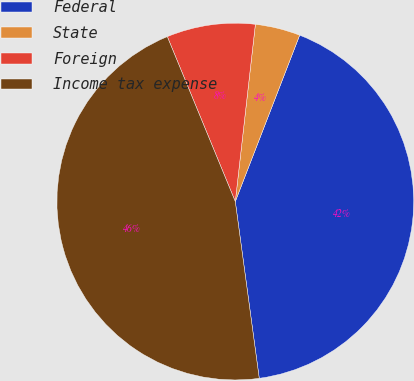Convert chart to OTSL. <chart><loc_0><loc_0><loc_500><loc_500><pie_chart><fcel>Federal<fcel>State<fcel>Foreign<fcel>Income tax expense<nl><fcel>41.98%<fcel>4.08%<fcel>8.02%<fcel>45.92%<nl></chart> 